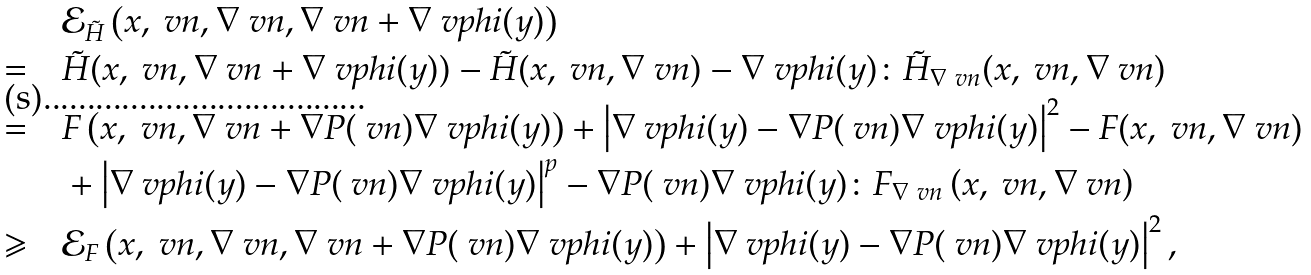<formula> <loc_0><loc_0><loc_500><loc_500>& \mathcal { E } _ { \tilde { H } } \left ( x , \ v n , \nabla \ v n , \nabla \ v n + \nabla \ v p h i ( y ) \right ) \\ = \quad & \tilde { H } ( x , \ v n , \nabla \ v n + \nabla \ v p h i ( y ) ) - \tilde { H } ( x , \ v n , \nabla \ v n ) - \nabla \ v p h i ( y ) \colon \tilde { H } _ { \nabla \ v n } ( x , \ v n , \nabla \ v n ) \\ = \quad & F \left ( x , \ v n , \nabla \ v n + \nabla P ( \ v n ) \nabla \ v p h i ( y ) \right ) + \left | \nabla \ v p h i ( y ) - \nabla P ( \ v n ) \nabla \ v p h i ( y ) \right | ^ { 2 } - F ( x , \ v n , \nabla \ v n ) \\ & + \left | \nabla \ v p h i ( y ) - \nabla P ( \ v n ) \nabla \ v p h i ( y ) \right | ^ { p } - \nabla P ( \ v n ) \nabla \ v p h i ( y ) \colon F _ { \nabla \ v n } \left ( x , \ v n , \nabla \ v n \right ) \\ \geqslant \quad & \mathcal { E } _ { F } \left ( x , \ v n , \nabla \ v n , \nabla \ v n + \nabla P ( \ v n ) \nabla \ v p h i ( y ) \right ) + \left | \nabla \ v p h i ( y ) - \nabla P ( \ v n ) \nabla \ v p h i ( y ) \right | ^ { 2 } ,</formula> 